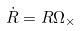Convert formula to latex. <formula><loc_0><loc_0><loc_500><loc_500>\dot { R } = R \Omega _ { \times }</formula> 